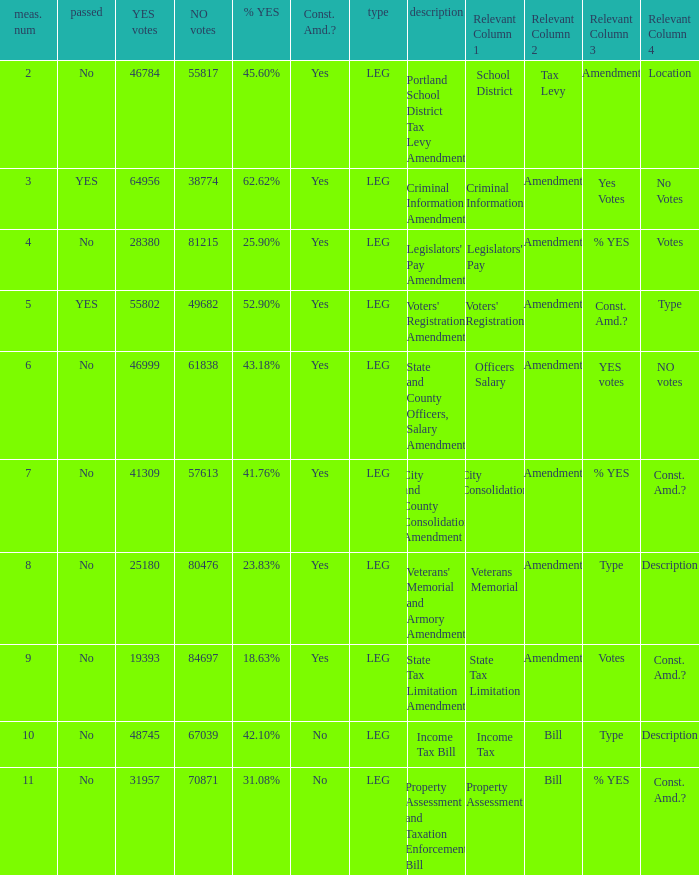Who had 41.76% yes votes City and County Consolidation Amendment. 